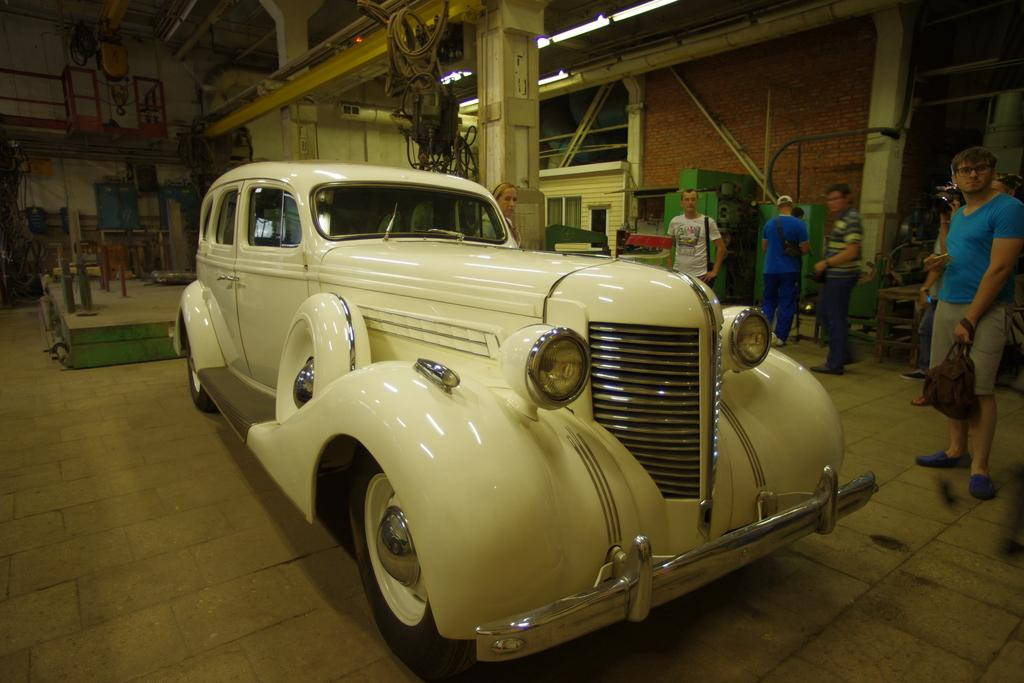Who or what is present in the image? There are people in the image. What type of vehicle can be seen in the image? There is a white-colored vehicle in the image. What else can be found in the room where the image was taken? There are objects in the room. Can you describe the lighting in the image? There are lights attached to the ceiling in the image. What type of pail is being used to climb the mountain in the image? There is no pail or mountain present in the image. What offer is being made by the people in the image? There is no offer being made by the people in the image; we cannot determine their intentions or actions based on the provided facts. 